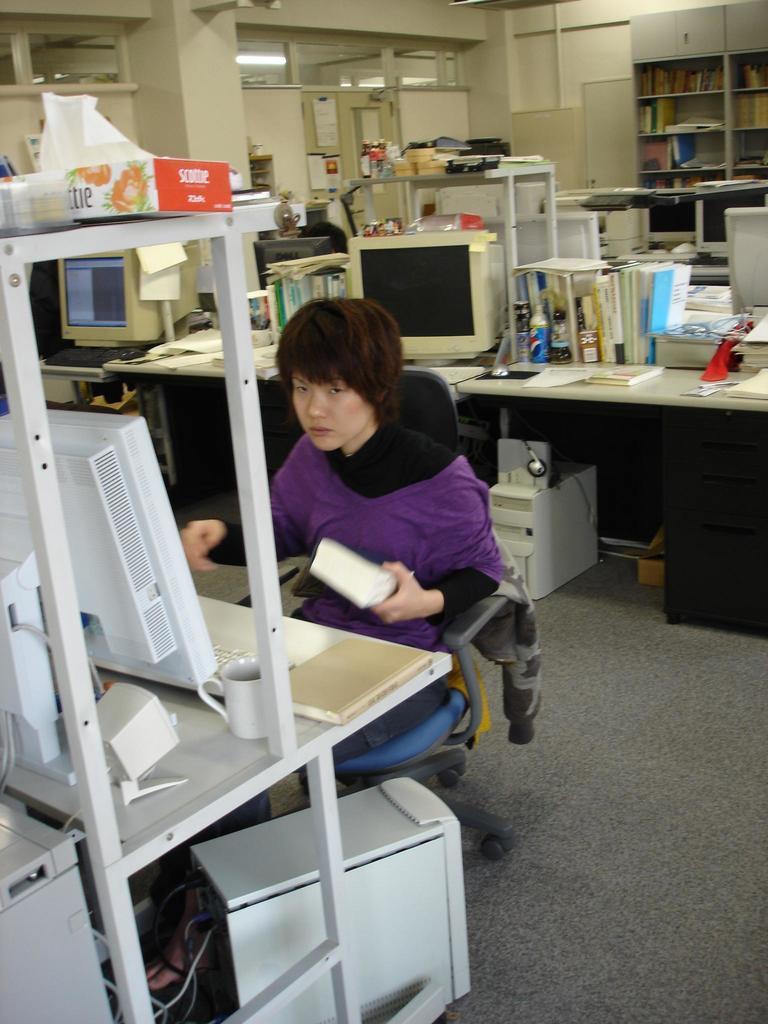Could you give a brief overview of what you see in this image? In this image I can see a person. I can see the computers and some other objects on the desk. At the top I can see the light. 